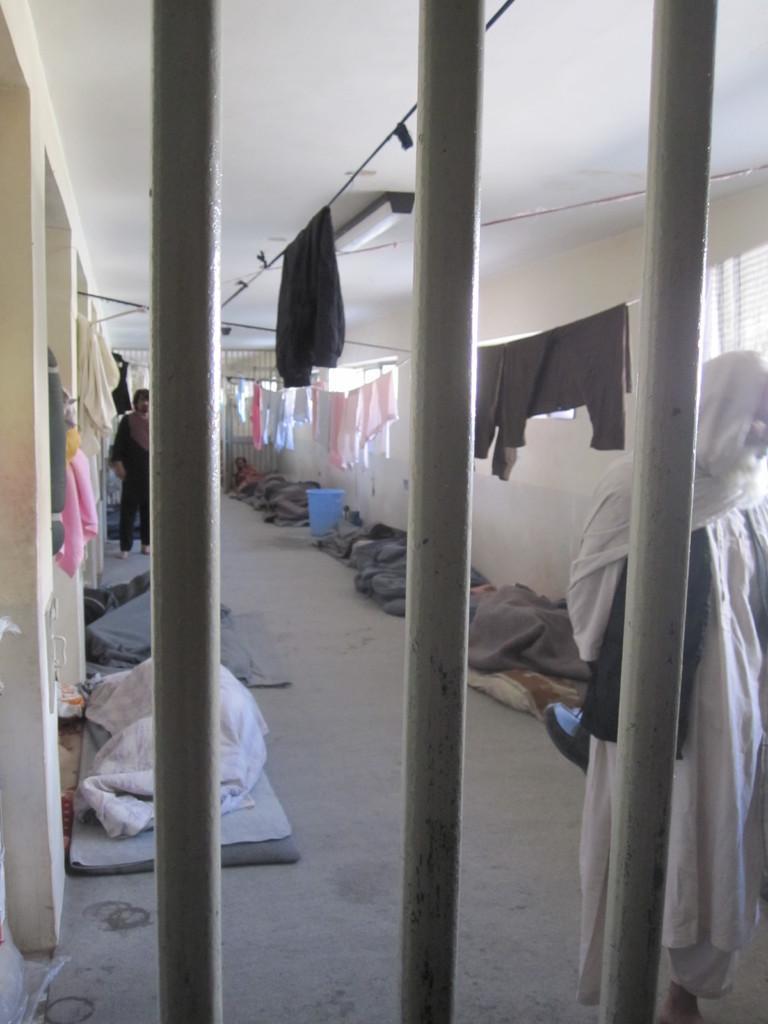In one or two sentences, can you explain what this image depicts? In the front of the image there are rods. Behind the rods on the floor there are few people. On the right side of the image there is a man standing. In the background there are ropes with clothes are hanging. And there is a wall with windows. 